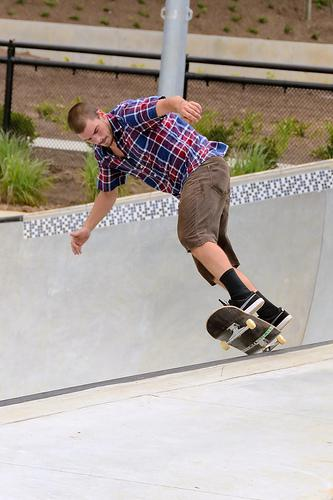Question: what is the man doing?
Choices:
A. Talking.
B. Sleeping.
C. Eating.
D. Skateboarding.
Answer with the letter. Answer: D Question: why is the man in the air?
Choices:
A. He is doing a trick.
B. He fell.
C. He is flying.
D. He jumped.
Answer with the letter. Answer: D Question: who is in the air?
Choices:
A. The man.
B. The dog.
C. The girl.
D. The bird.
Answer with the letter. Answer: A Question: when was this picture taken?
Choices:
A. At night.
B. During the day.
C. Noon.
D. Sunset.
Answer with the letter. Answer: B 